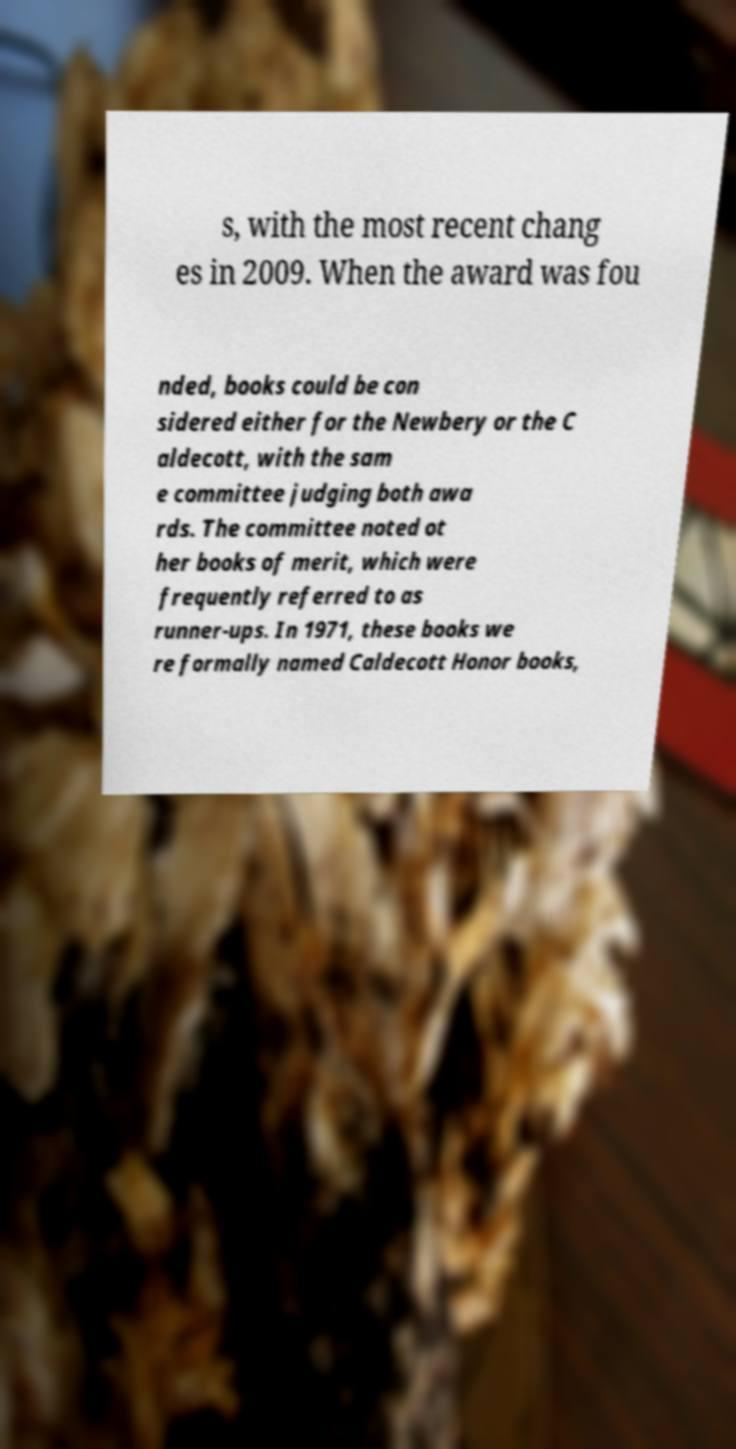Can you accurately transcribe the text from the provided image for me? s, with the most recent chang es in 2009. When the award was fou nded, books could be con sidered either for the Newbery or the C aldecott, with the sam e committee judging both awa rds. The committee noted ot her books of merit, which were frequently referred to as runner-ups. In 1971, these books we re formally named Caldecott Honor books, 